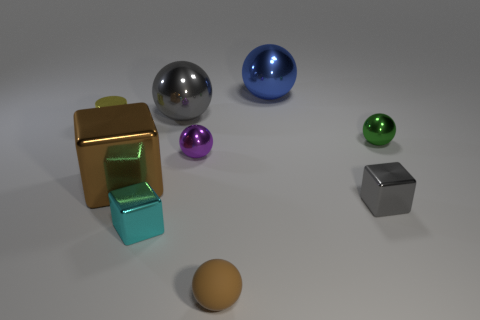What is the material of the cube that is the same color as the matte sphere?
Ensure brevity in your answer.  Metal. Are there the same number of matte objects in front of the rubber object and small gray shiny things?
Offer a very short reply. No. What shape is the purple object that is the same size as the yellow cylinder?
Your answer should be very brief. Sphere. What number of other objects are there of the same shape as the blue metallic thing?
Provide a succinct answer. 4. Do the purple metallic ball and the gray metal object that is left of the small brown sphere have the same size?
Your answer should be very brief. No. What number of objects are large balls that are to the left of the large blue shiny ball or small purple metallic spheres?
Offer a very short reply. 2. There is a gray metallic thing behind the tiny purple metal ball; what shape is it?
Provide a succinct answer. Sphere. Are there an equal number of big brown shiny objects that are right of the tiny gray object and tiny matte objects that are right of the large blue metal sphere?
Make the answer very short. Yes. The shiny object that is both behind the purple metallic thing and right of the large blue sphere is what color?
Provide a succinct answer. Green. What is the material of the object that is to the right of the gray metal thing to the right of the big blue shiny ball?
Provide a short and direct response. Metal. 